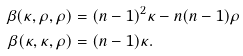<formula> <loc_0><loc_0><loc_500><loc_500>\beta ( \kappa , \rho , \rho ) & = ( n - 1 ) ^ { 2 } \kappa - n ( n - 1 ) \rho \\ \beta ( \kappa , \kappa , \rho ) & = ( n - 1 ) \kappa .</formula> 